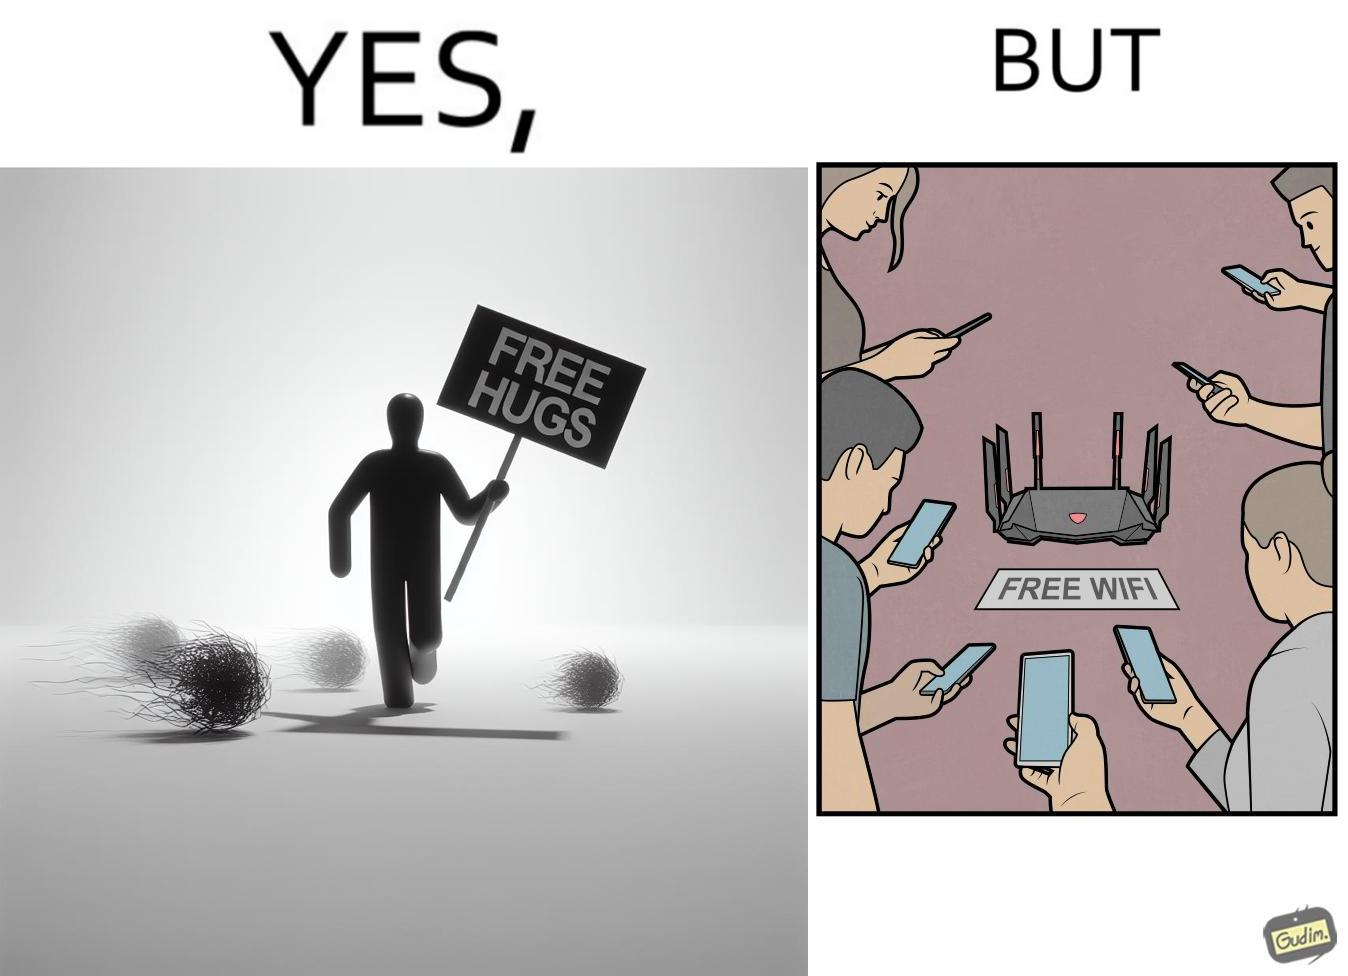Is there satirical content in this image? Yes, this image is satirical. 